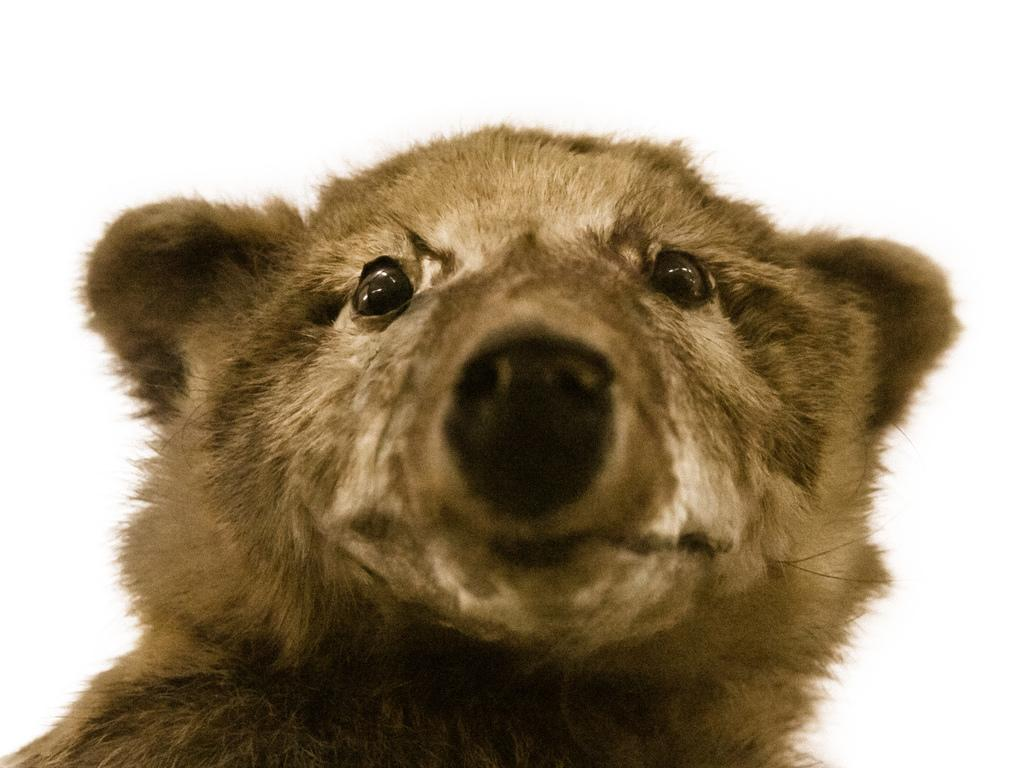What is the main subject of the picture? The main subject of the picture is a bear face. Can you describe the background of the image? The background appears brighter in the image. How many brothers does the bear face have in the image? There are no brothers mentioned or depicted in the image, as it features only a bear face. What type of coil is used for learning in the image? There is no coil or reference to learning present in the image; it only contains a bear face and a brighter background. 